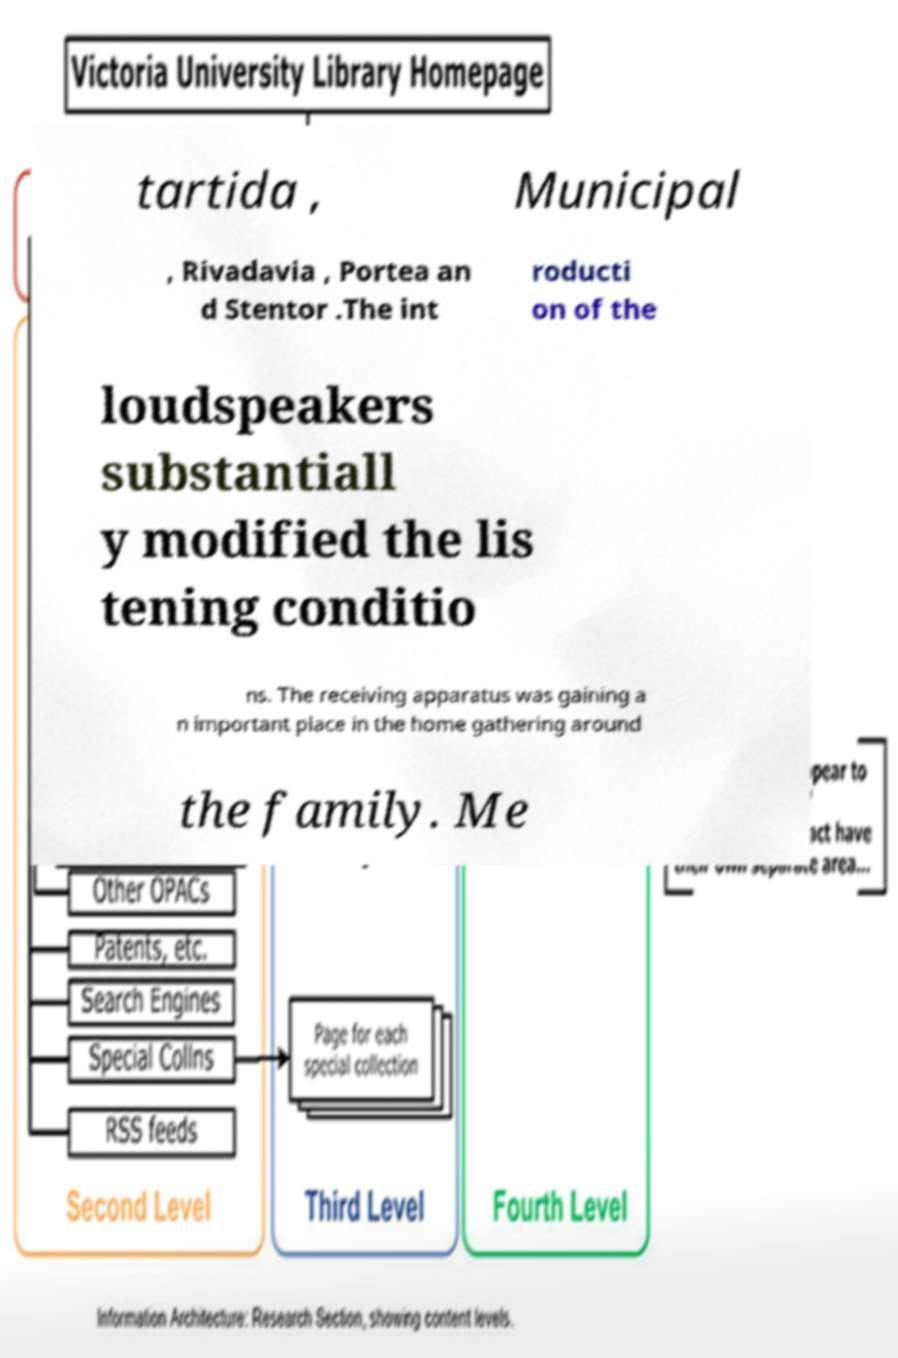Could you extract and type out the text from this image? tartida , Municipal , Rivadavia , Portea an d Stentor .The int roducti on of the loudspeakers substantiall y modified the lis tening conditio ns. The receiving apparatus was gaining a n important place in the home gathering around the family. Me 